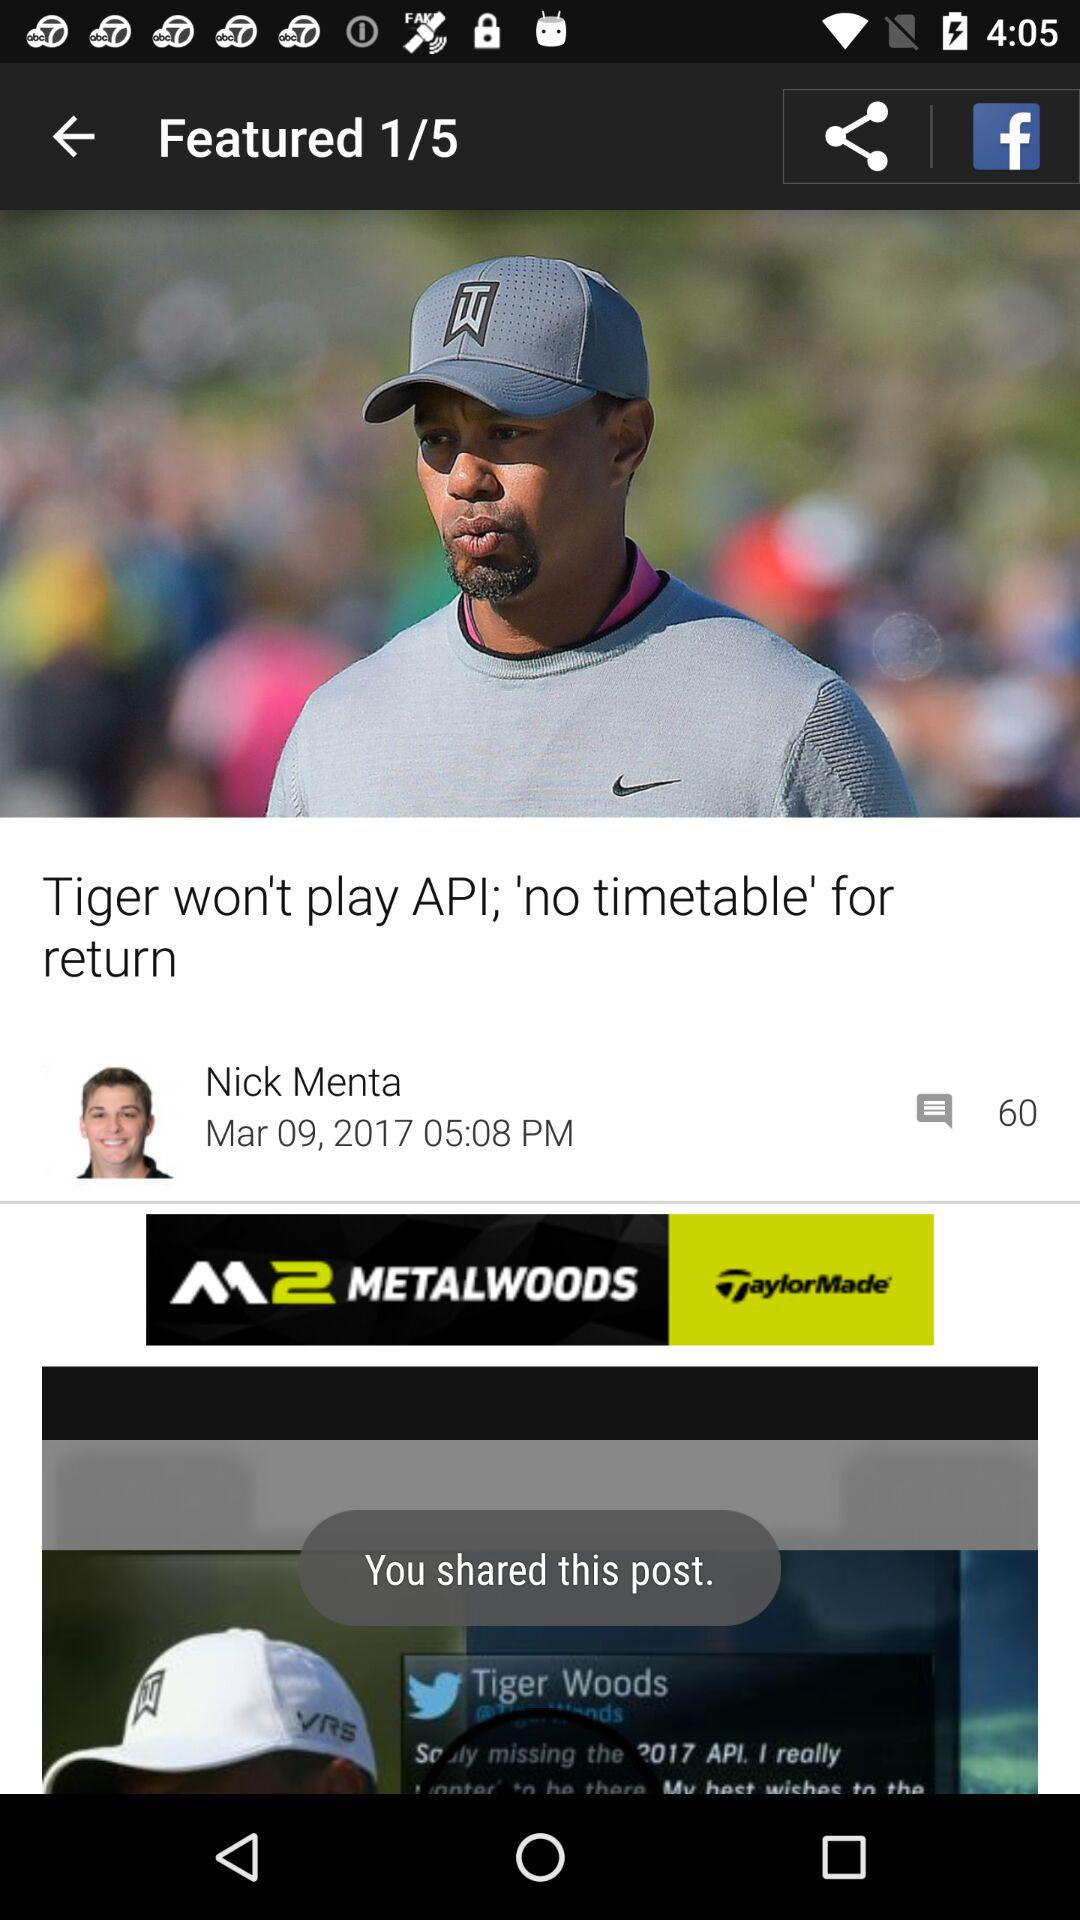What is the number of pages in the article? The number of pages in the article is 5. 